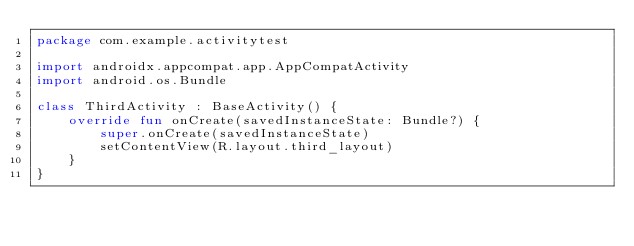Convert code to text. <code><loc_0><loc_0><loc_500><loc_500><_Kotlin_>package com.example.activitytest

import androidx.appcompat.app.AppCompatActivity
import android.os.Bundle

class ThirdActivity : BaseActivity() {
    override fun onCreate(savedInstanceState: Bundle?) {
        super.onCreate(savedInstanceState)
        setContentView(R.layout.third_layout)
    }
}</code> 